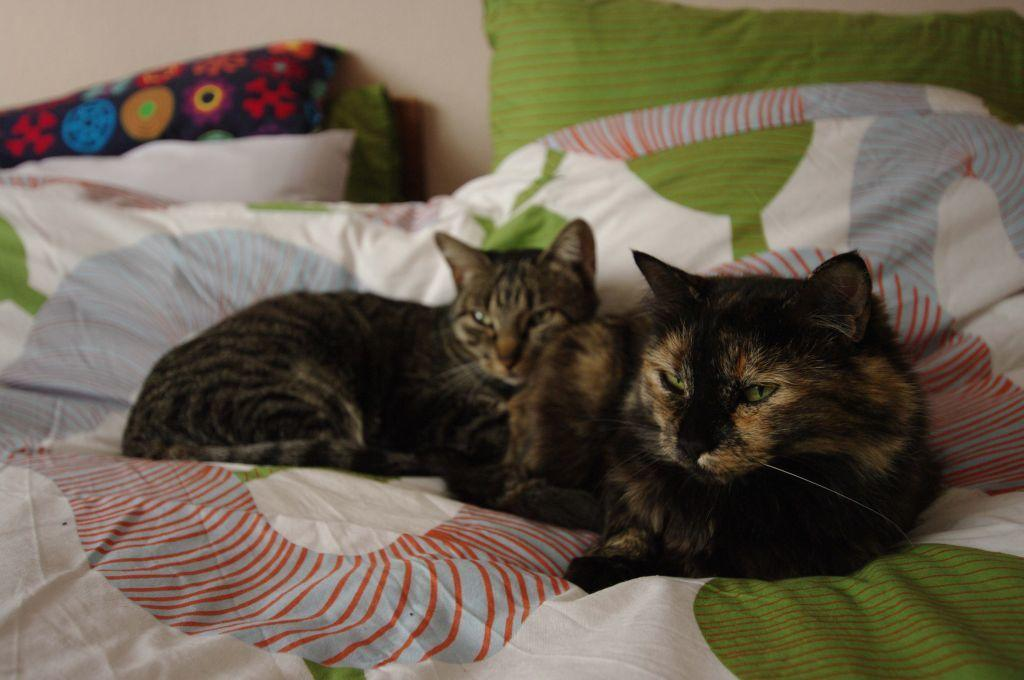What animals are present in the image? There are two black cats in the image. Where are the cats located? The cats are sitting on a bed. What can be seen in the background of the image? There is a green pillow in the background of the image. What stage of development are the worms in the image? There are no worms present in the image; it features two black cats sitting on a bed. 